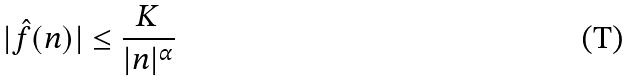<formula> <loc_0><loc_0><loc_500><loc_500>| \hat { f } ( n ) | \leq \frac { K } { | n | ^ { \alpha } }</formula> 